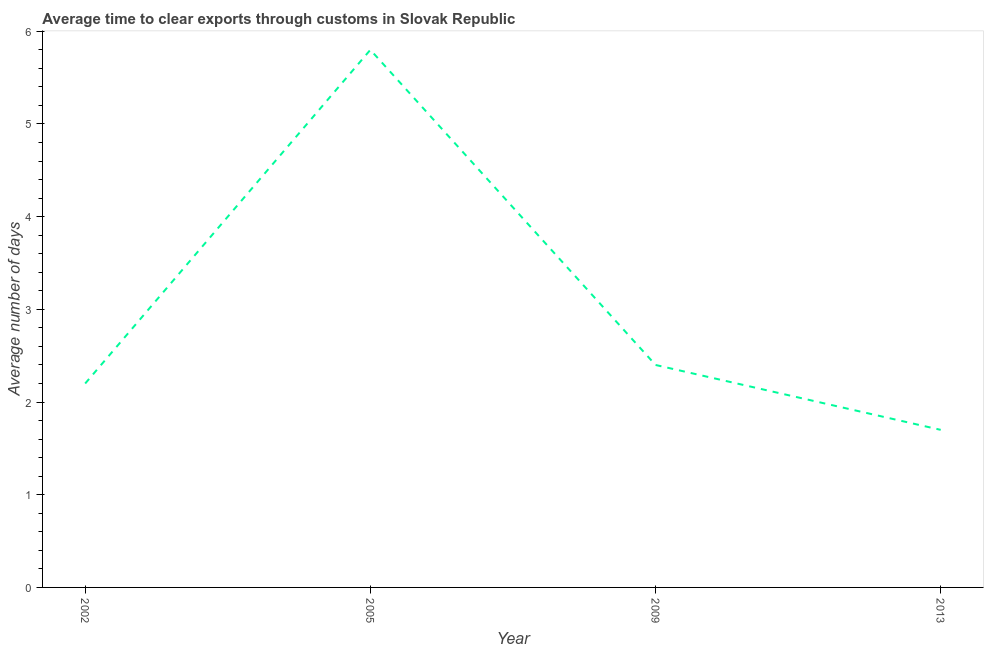Across all years, what is the maximum time to clear exports through customs?
Offer a very short reply. 5.8. In which year was the time to clear exports through customs minimum?
Your response must be concise. 2013. What is the sum of the time to clear exports through customs?
Your answer should be compact. 12.1. What is the average time to clear exports through customs per year?
Provide a short and direct response. 3.02. In how many years, is the time to clear exports through customs greater than 3.2 days?
Your response must be concise. 1. Do a majority of the years between 2009 and 2005 (inclusive) have time to clear exports through customs greater than 1.6 days?
Provide a short and direct response. No. What is the ratio of the time to clear exports through customs in 2002 to that in 2005?
Give a very brief answer. 0.38. Is the time to clear exports through customs in 2002 less than that in 2013?
Give a very brief answer. No. Is the difference between the time to clear exports through customs in 2005 and 2013 greater than the difference between any two years?
Your answer should be compact. Yes. Does the time to clear exports through customs monotonically increase over the years?
Your answer should be compact. No. What is the title of the graph?
Your answer should be very brief. Average time to clear exports through customs in Slovak Republic. What is the label or title of the Y-axis?
Offer a terse response. Average number of days. What is the Average number of days in 2002?
Your answer should be compact. 2.2. What is the Average number of days of 2005?
Offer a terse response. 5.8. What is the Average number of days of 2009?
Ensure brevity in your answer.  2.4. What is the Average number of days of 2013?
Your response must be concise. 1.7. What is the difference between the Average number of days in 2002 and 2009?
Ensure brevity in your answer.  -0.2. What is the difference between the Average number of days in 2002 and 2013?
Provide a succinct answer. 0.5. What is the difference between the Average number of days in 2005 and 2013?
Your response must be concise. 4.1. What is the difference between the Average number of days in 2009 and 2013?
Keep it short and to the point. 0.7. What is the ratio of the Average number of days in 2002 to that in 2005?
Your response must be concise. 0.38. What is the ratio of the Average number of days in 2002 to that in 2009?
Give a very brief answer. 0.92. What is the ratio of the Average number of days in 2002 to that in 2013?
Your answer should be compact. 1.29. What is the ratio of the Average number of days in 2005 to that in 2009?
Your response must be concise. 2.42. What is the ratio of the Average number of days in 2005 to that in 2013?
Your answer should be compact. 3.41. What is the ratio of the Average number of days in 2009 to that in 2013?
Provide a short and direct response. 1.41. 